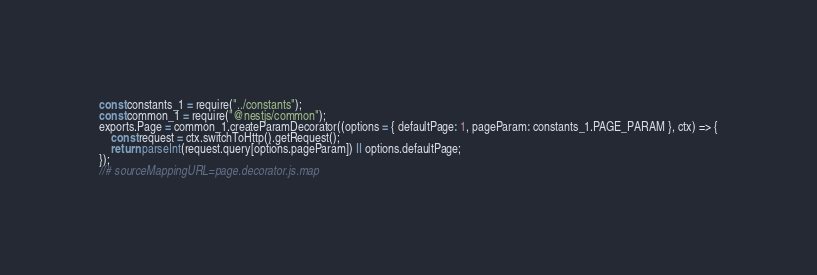<code> <loc_0><loc_0><loc_500><loc_500><_JavaScript_>const constants_1 = require("../constants");
const common_1 = require("@nestjs/common");
exports.Page = common_1.createParamDecorator((options = { defaultPage: 1, pageParam: constants_1.PAGE_PARAM }, ctx) => {
    const request = ctx.switchToHttp().getRequest();
    return parseInt(request.query[options.pageParam]) || options.defaultPage;
});
//# sourceMappingURL=page.decorator.js.map</code> 